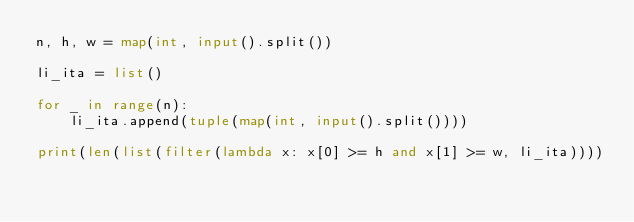Convert code to text. <code><loc_0><loc_0><loc_500><loc_500><_Python_>n, h, w = map(int, input().split())

li_ita = list()

for _ in range(n):
    li_ita.append(tuple(map(int, input().split())))

print(len(list(filter(lambda x: x[0] >= h and x[1] >= w, li_ita))))</code> 